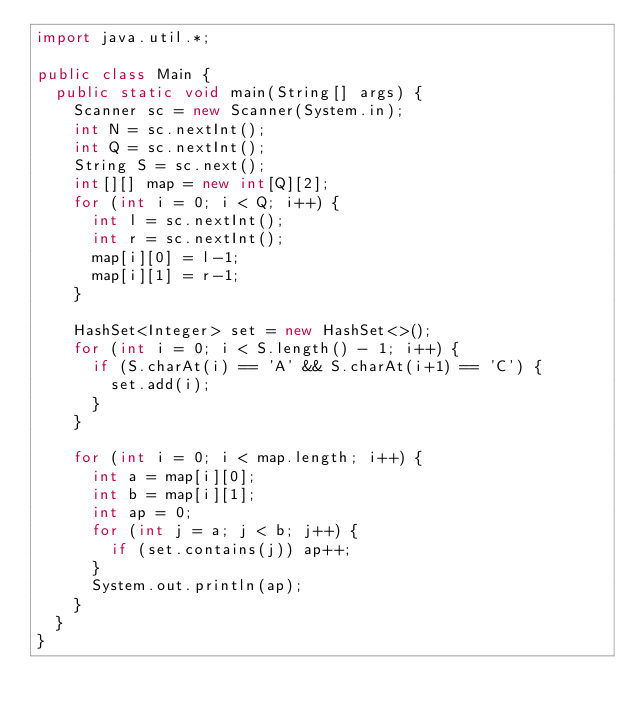<code> <loc_0><loc_0><loc_500><loc_500><_Java_>import java.util.*;

public class Main {
	public static void main(String[] args) {
		Scanner sc = new Scanner(System.in);
		int N = sc.nextInt();
		int Q = sc.nextInt();
		String S = sc.next();
		int[][] map = new int[Q][2];
		for (int i = 0; i < Q; i++) {
			int l = sc.nextInt();
			int r = sc.nextInt();
			map[i][0] = l-1;
			map[i][1] = r-1;
		}

		HashSet<Integer> set = new HashSet<>();
		for (int i = 0; i < S.length() - 1; i++) {
			if (S.charAt(i) == 'A' && S.charAt(i+1) == 'C') {
				set.add(i);
			}
		}

		for (int i = 0; i < map.length; i++) {
			int a = map[i][0];
			int b = map[i][1];
			int ap = 0;
			for (int j = a; j < b; j++) {
				if (set.contains(j)) ap++;
			}
			System.out.println(ap);
		}
	}
}</code> 